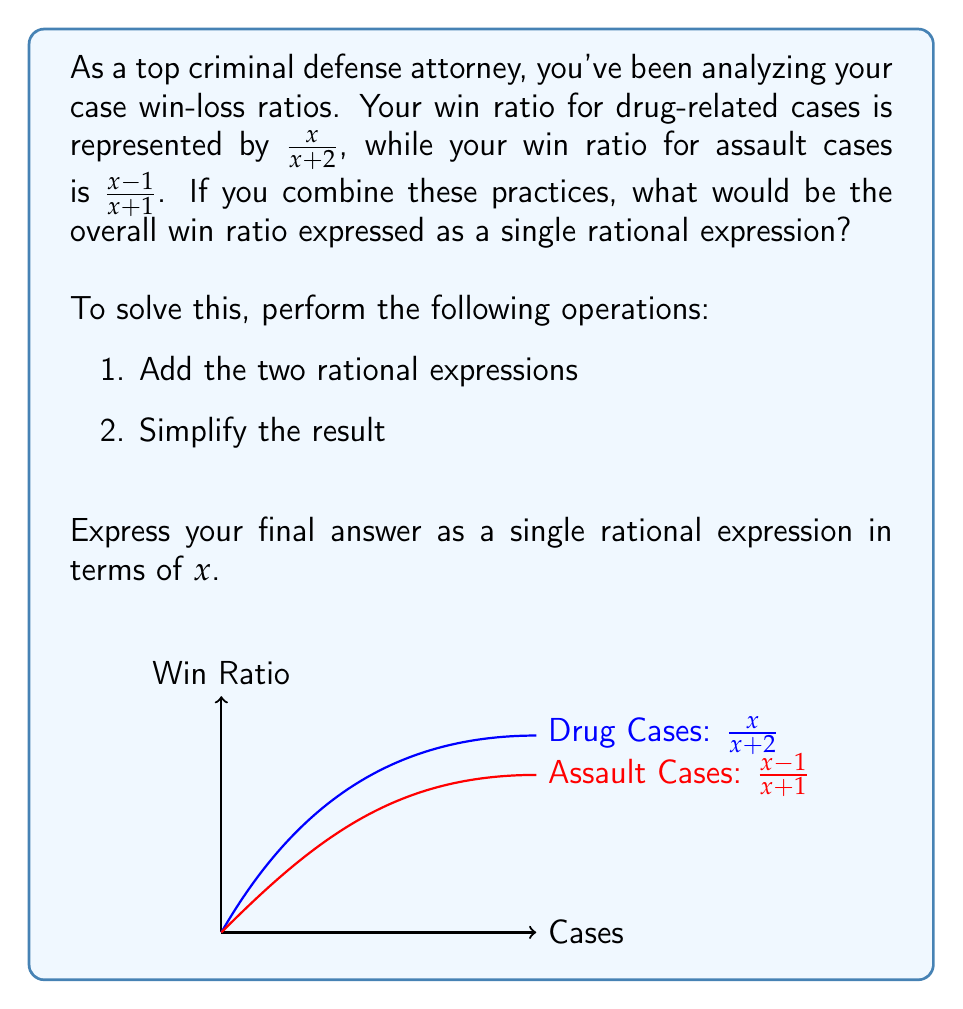Provide a solution to this math problem. Let's approach this step-by-step:

1) To add rational expressions, we need a common denominator. The common denominator will be the product of the individual denominators:

   $(x+2)(x+1)$

2) Now, we multiply each numerator by the denominator of the other fraction:

   $\frac{x}{x+2} \cdot \frac{x+1}{x+1} + \frac{x-1}{x+1} \cdot \frac{x+2}{x+2}$

3) This gives us:

   $\frac{x(x+1)}{(x+2)(x+1)} + \frac{(x-1)(x+2)}{(x+1)(x+2)}$

4) Simplify the numerators:

   $\frac{x^2+x}{(x+2)(x+1)} + \frac{x^2+x-2}{(x+1)(x+2)}$

5) Now that we have a common denominator, we can add the numerators:

   $\frac{x^2+x + x^2+x-2}{(x+1)(x+2)}$

6) Simplify the numerator:

   $\frac{2x^2+2x-2}{(x+1)(x+2)}$

7) Factor out the common factor in the numerator:

   $\frac{2(x^2+x-1)}{(x+1)(x+2)}$

This is our final simplified rational expression representing the overall win ratio.
Answer: $\frac{2(x^2+x-1)}{(x+1)(x+2)}$ 